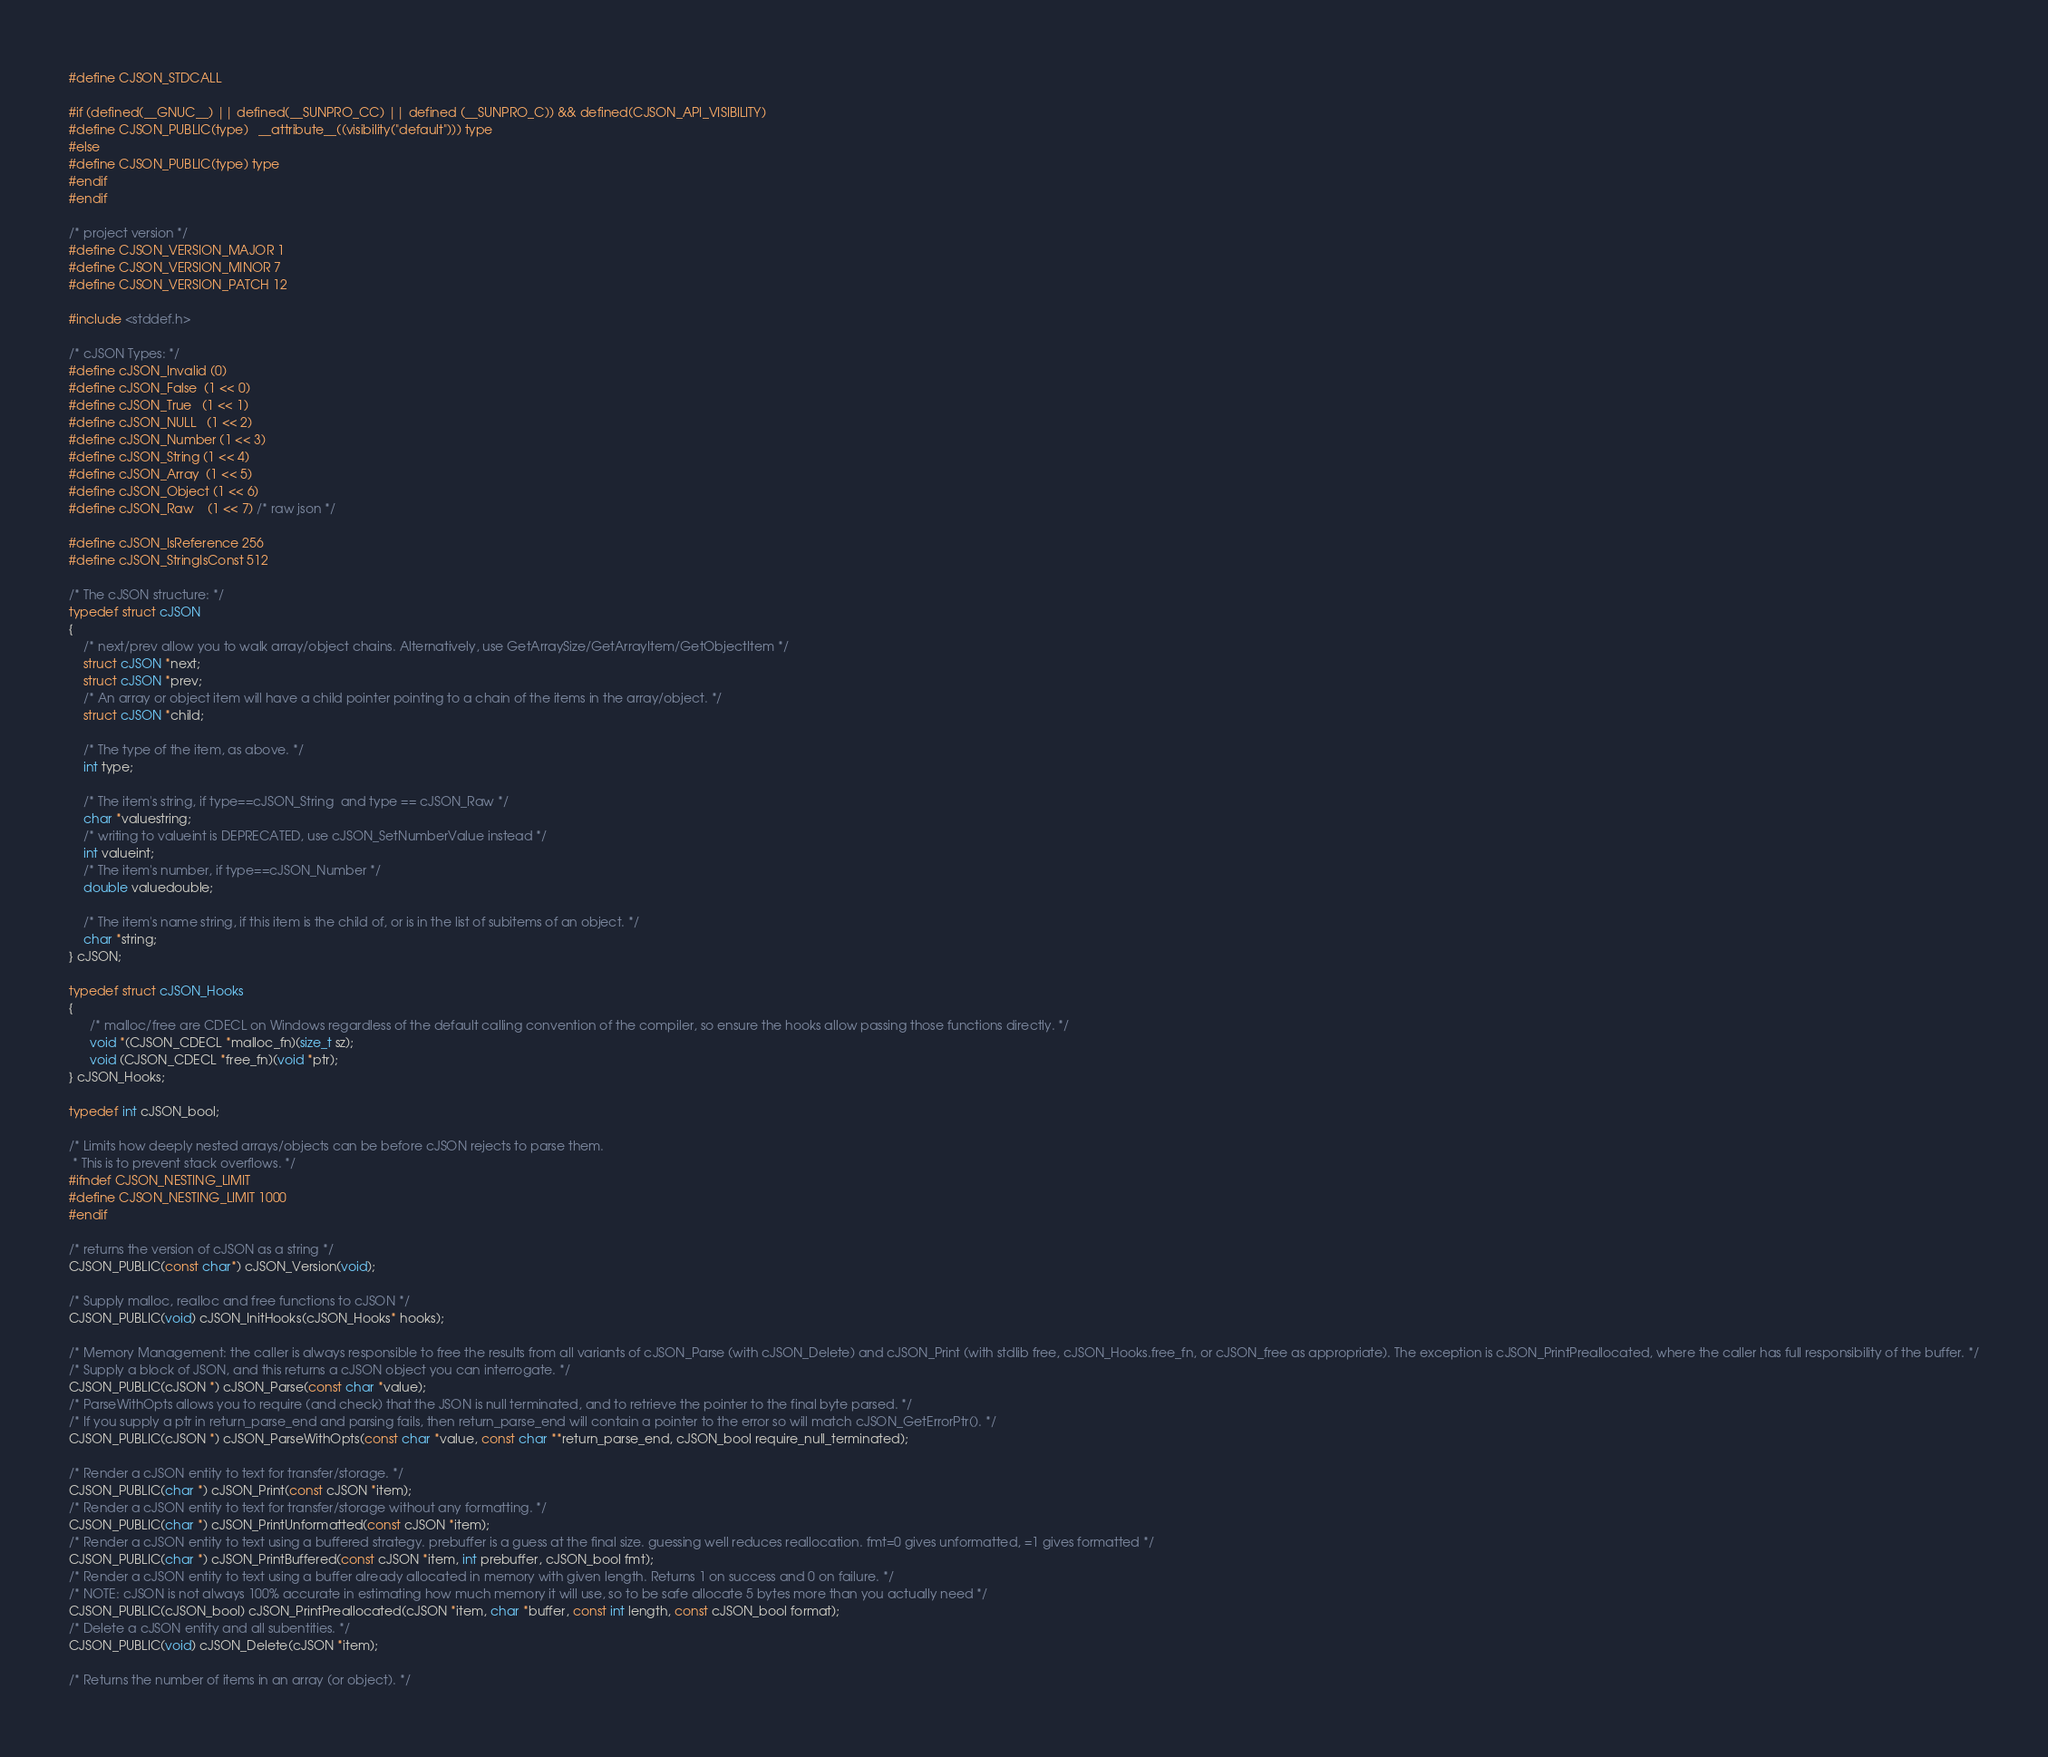Convert code to text. <code><loc_0><loc_0><loc_500><loc_500><_C_>#define CJSON_STDCALL

#if (defined(__GNUC__) || defined(__SUNPRO_CC) || defined (__SUNPRO_C)) && defined(CJSON_API_VISIBILITY)
#define CJSON_PUBLIC(type)   __attribute__((visibility("default"))) type
#else
#define CJSON_PUBLIC(type) type
#endif
#endif

/* project version */
#define CJSON_VERSION_MAJOR 1
#define CJSON_VERSION_MINOR 7
#define CJSON_VERSION_PATCH 12

#include <stddef.h>

/* cJSON Types: */
#define cJSON_Invalid (0)
#define cJSON_False  (1 << 0)
#define cJSON_True   (1 << 1)
#define cJSON_NULL   (1 << 2)
#define cJSON_Number (1 << 3)
#define cJSON_String (1 << 4)
#define cJSON_Array  (1 << 5)
#define cJSON_Object (1 << 6)
#define cJSON_Raw    (1 << 7) /* raw json */

#define cJSON_IsReference 256
#define cJSON_StringIsConst 512

/* The cJSON structure: */
typedef struct cJSON
{
    /* next/prev allow you to walk array/object chains. Alternatively, use GetArraySize/GetArrayItem/GetObjectItem */
    struct cJSON *next;
    struct cJSON *prev;
    /* An array or object item will have a child pointer pointing to a chain of the items in the array/object. */
    struct cJSON *child;

    /* The type of the item, as above. */
    int type;

    /* The item's string, if type==cJSON_String  and type == cJSON_Raw */
    char *valuestring;
    /* writing to valueint is DEPRECATED, use cJSON_SetNumberValue instead */
    int valueint;
    /* The item's number, if type==cJSON_Number */
    double valuedouble;

    /* The item's name string, if this item is the child of, or is in the list of subitems of an object. */
    char *string;
} cJSON;

typedef struct cJSON_Hooks
{
      /* malloc/free are CDECL on Windows regardless of the default calling convention of the compiler, so ensure the hooks allow passing those functions directly. */
      void *(CJSON_CDECL *malloc_fn)(size_t sz);
      void (CJSON_CDECL *free_fn)(void *ptr);
} cJSON_Hooks;

typedef int cJSON_bool;

/* Limits how deeply nested arrays/objects can be before cJSON rejects to parse them.
 * This is to prevent stack overflows. */
#ifndef CJSON_NESTING_LIMIT
#define CJSON_NESTING_LIMIT 1000
#endif

/* returns the version of cJSON as a string */
CJSON_PUBLIC(const char*) cJSON_Version(void);

/* Supply malloc, realloc and free functions to cJSON */
CJSON_PUBLIC(void) cJSON_InitHooks(cJSON_Hooks* hooks);

/* Memory Management: the caller is always responsible to free the results from all variants of cJSON_Parse (with cJSON_Delete) and cJSON_Print (with stdlib free, cJSON_Hooks.free_fn, or cJSON_free as appropriate). The exception is cJSON_PrintPreallocated, where the caller has full responsibility of the buffer. */
/* Supply a block of JSON, and this returns a cJSON object you can interrogate. */
CJSON_PUBLIC(cJSON *) cJSON_Parse(const char *value);
/* ParseWithOpts allows you to require (and check) that the JSON is null terminated, and to retrieve the pointer to the final byte parsed. */
/* If you supply a ptr in return_parse_end and parsing fails, then return_parse_end will contain a pointer to the error so will match cJSON_GetErrorPtr(). */
CJSON_PUBLIC(cJSON *) cJSON_ParseWithOpts(const char *value, const char **return_parse_end, cJSON_bool require_null_terminated);

/* Render a cJSON entity to text for transfer/storage. */
CJSON_PUBLIC(char *) cJSON_Print(const cJSON *item);
/* Render a cJSON entity to text for transfer/storage without any formatting. */
CJSON_PUBLIC(char *) cJSON_PrintUnformatted(const cJSON *item);
/* Render a cJSON entity to text using a buffered strategy. prebuffer is a guess at the final size. guessing well reduces reallocation. fmt=0 gives unformatted, =1 gives formatted */
CJSON_PUBLIC(char *) cJSON_PrintBuffered(const cJSON *item, int prebuffer, cJSON_bool fmt);
/* Render a cJSON entity to text using a buffer already allocated in memory with given length. Returns 1 on success and 0 on failure. */
/* NOTE: cJSON is not always 100% accurate in estimating how much memory it will use, so to be safe allocate 5 bytes more than you actually need */
CJSON_PUBLIC(cJSON_bool) cJSON_PrintPreallocated(cJSON *item, char *buffer, const int length, const cJSON_bool format);
/* Delete a cJSON entity and all subentities. */
CJSON_PUBLIC(void) cJSON_Delete(cJSON *item);

/* Returns the number of items in an array (or object). */</code> 